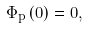<formula> <loc_0><loc_0><loc_500><loc_500>\Phi _ { p } \left ( 0 \right ) = 0 ,</formula> 